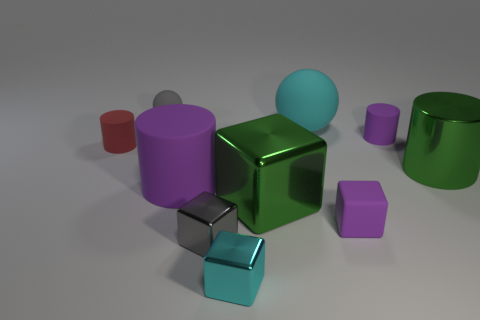Is the number of red matte objects behind the tiny cyan metallic block greater than the number of cyan shiny balls?
Give a very brief answer. Yes. There is a matte ball to the right of the cyan metal thing; is it the same size as the big green metallic block?
Keep it short and to the point. Yes. What color is the matte object that is both in front of the big green cylinder and left of the small gray metal thing?
Offer a terse response. Purple. There is a purple matte thing that is the same size as the cyan ball; what shape is it?
Offer a terse response. Cylinder. Is there a big matte object that has the same color as the tiny rubber block?
Keep it short and to the point. Yes. Is the number of big cyan spheres that are right of the cyan matte object the same as the number of brown metallic cubes?
Ensure brevity in your answer.  Yes. Do the matte block and the large matte cylinder have the same color?
Offer a very short reply. Yes. How big is the cylinder that is behind the green cylinder and right of the red cylinder?
Offer a terse response. Small. The small cube that is made of the same material as the tiny red cylinder is what color?
Offer a terse response. Purple. How many gray blocks are the same material as the small cyan block?
Provide a succinct answer. 1. 